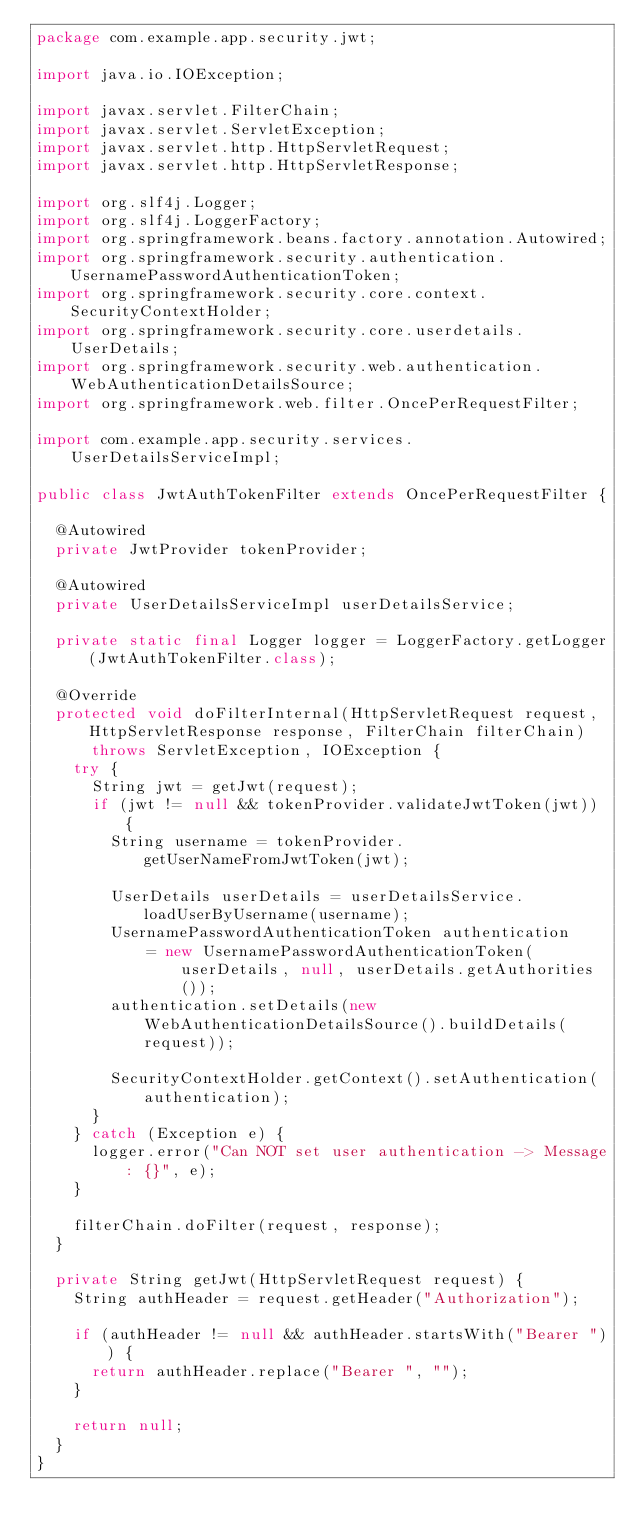<code> <loc_0><loc_0><loc_500><loc_500><_Java_>package com.example.app.security.jwt;

import java.io.IOException;

import javax.servlet.FilterChain;
import javax.servlet.ServletException;
import javax.servlet.http.HttpServletRequest;
import javax.servlet.http.HttpServletResponse;

import org.slf4j.Logger;
import org.slf4j.LoggerFactory;
import org.springframework.beans.factory.annotation.Autowired;
import org.springframework.security.authentication.UsernamePasswordAuthenticationToken;
import org.springframework.security.core.context.SecurityContextHolder;
import org.springframework.security.core.userdetails.UserDetails;
import org.springframework.security.web.authentication.WebAuthenticationDetailsSource;
import org.springframework.web.filter.OncePerRequestFilter;

import com.example.app.security.services.UserDetailsServiceImpl;

public class JwtAuthTokenFilter extends OncePerRequestFilter {

	@Autowired
	private JwtProvider tokenProvider;
	
	@Autowired
	private UserDetailsServiceImpl userDetailsService;
	
	private static final Logger logger = LoggerFactory.getLogger(JwtAuthTokenFilter.class);
	
	@Override
	protected void doFilterInternal(HttpServletRequest request, HttpServletResponse response, FilterChain filterChain)
			throws ServletException, IOException {
		try {
			String jwt = getJwt(request);
			if (jwt != null && tokenProvider.validateJwtToken(jwt)) {
				String username = tokenProvider.getUserNameFromJwtToken(jwt);
				
				UserDetails userDetails = userDetailsService.loadUserByUsername(username);
				UsernamePasswordAuthenticationToken authentication
						= new UsernamePasswordAuthenticationToken(userDetails, null, userDetails.getAuthorities());
				authentication.setDetails(new WebAuthenticationDetailsSource().buildDetails(request));
				
				SecurityContextHolder.getContext().setAuthentication(authentication);
			}
		} catch (Exception e) {
			logger.error("Can NOT set user authentication -> Message: {}", e);
		}
		
		filterChain.doFilter(request, response);
	}

	private String getJwt(HttpServletRequest request) {
		String authHeader = request.getHeader("Authorization");
		
		if (authHeader != null && authHeader.startsWith("Bearer ")) {
			return authHeader.replace("Bearer ", "");
		}
		
		return null;
	}
}
</code> 